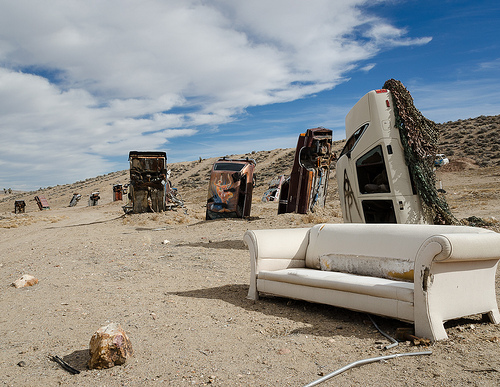<image>
Is there a car above the sofa? No. The car is not positioned above the sofa. The vertical arrangement shows a different relationship. 